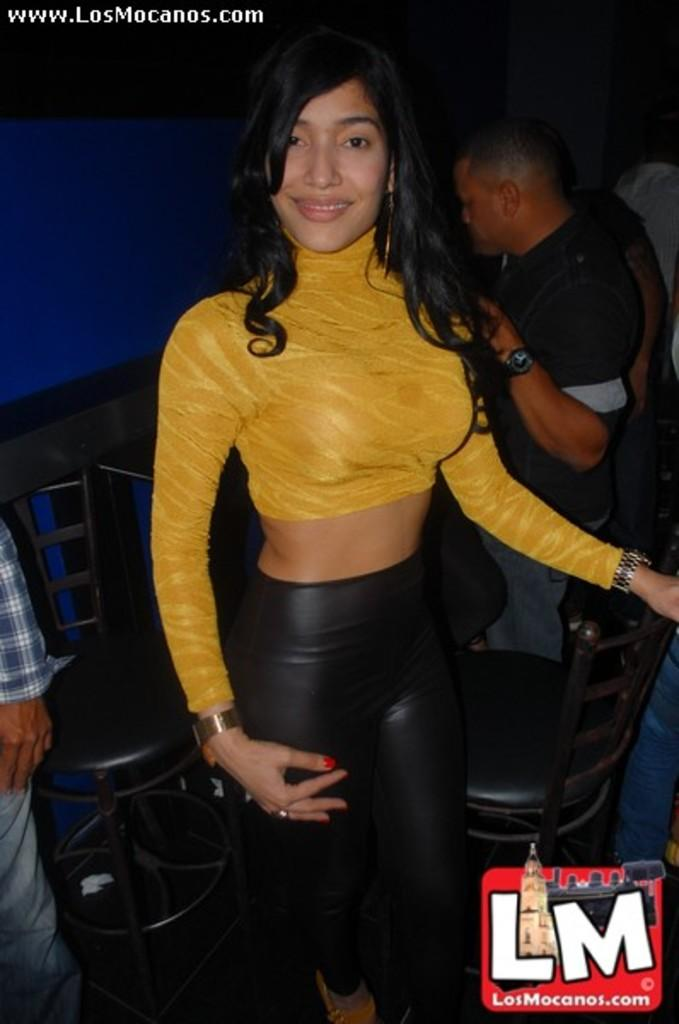What is the main subject of the image? There is a lady in the image. What is the lady doing in the image? The lady is standing. What is the lady wearing in the image? The lady is wearing a yellow dress and a watch. Is there any text or symbol in the image? Yes, there is a logo on the right bottom side of the image. What type of glass is the lady holding in the image? There is no glass present in the image; the lady is not holding anything. 